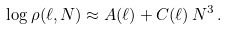<formula> <loc_0><loc_0><loc_500><loc_500>\log \rho ( \ell , N ) \approx A ( \ell ) + C ( \ell ) \, N ^ { 3 } \, .</formula> 